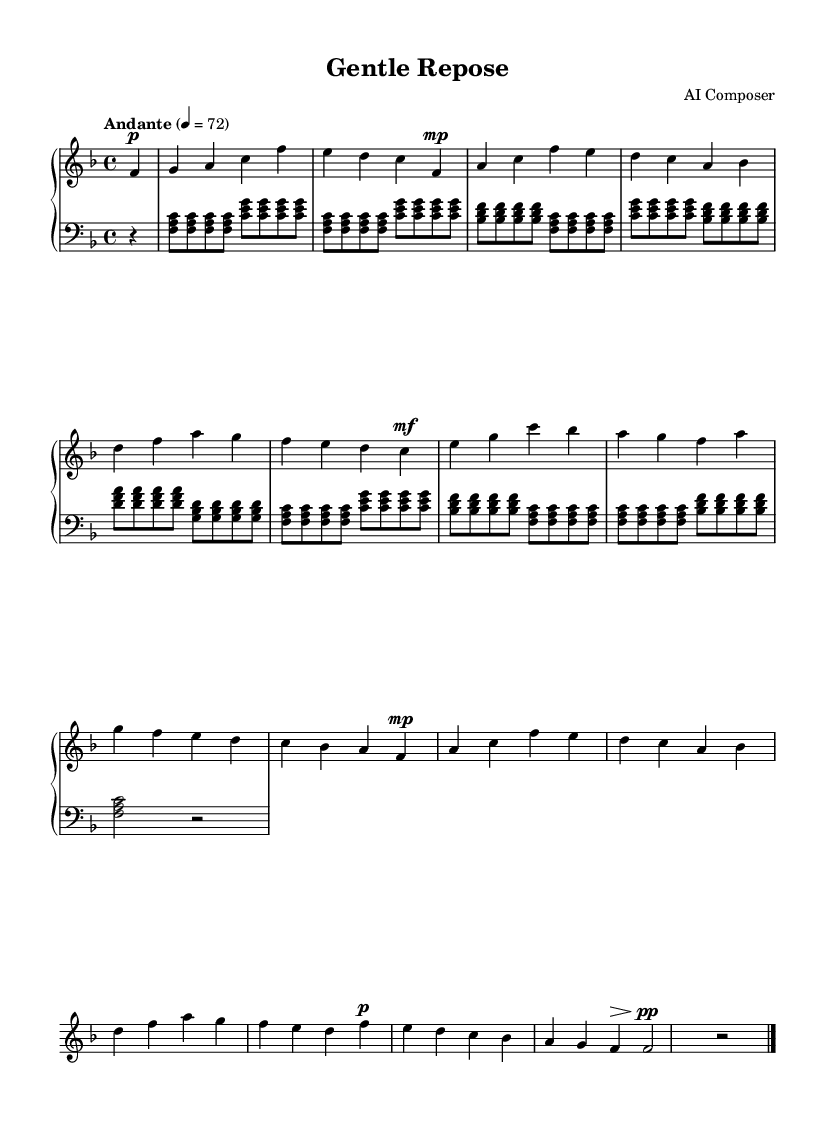what is the key signature of this music? The key signature is F major, which has one flat (B flat). This can be determined by looking at the key signature at the beginning of the staff.
Answer: F major what is the time signature of this music? The time signature is 4/4, which means there are four beats in each measure, and the quarter note gets one beat. This is indicated at the beginning of the score next to the key signature.
Answer: 4/4 what is the tempo marking in this music? The tempo marking is "Andante," which indicates a moderate pace. This is specified above the staff on the score.
Answer: Andante how many sections are in the piece? The piece contains three primary sections (A, B, A') and a coda, indicating that after exploring the B section, it returns to the A section with minor variation. This can be identified by the labels provided in the score.
Answer: Three what is the dynamic marking for the introduction? The dynamic marking for the introduction is piano, as indicated by the "p" symbol before the first note. This means to play softly.
Answer: piano what is the final dynamic marking in this music? The final dynamic marking is pianissimo, as indicated by the "pp" symbol at the end of the piece. This instructs the performer to play very softly.
Answer: pianissimo what is the primary theme of this ballad? The primary theme of this ballad is characterized by gentle and flowing melodic lines with expressive dynamics, common in Romantic music. This is inferred from the overall use of legato phrasing and the emotional quality present in the A sections of the music.
Answer: Gentle and flowing melodic lines 